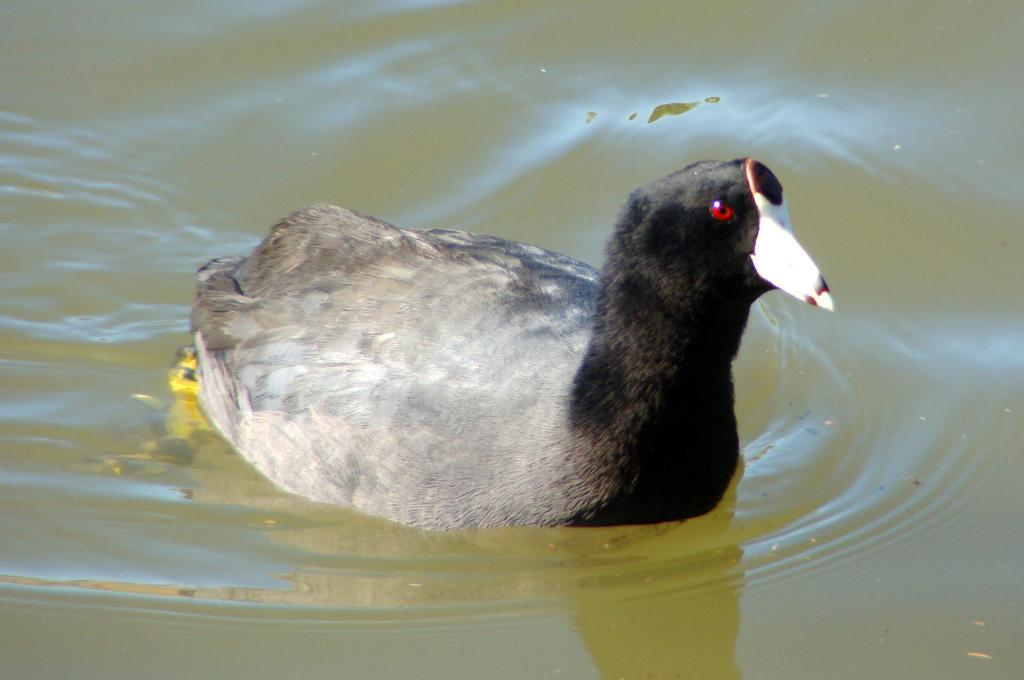What type of animal can be seen in the image? There is a bird in the image. What is the bird doing in the image? The bird is swimming in the water. What colors are present on the bird? The bird is black and white in color. What can be seen in the background of the image? There is water visible in the background of the image. What type of disease is affecting the bird in the image? There is no indication of any disease affecting the bird in the image. What type of silk material can be seen on the bird in the image? There is: There is no silk material present on the bird in the image. 